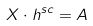<formula> <loc_0><loc_0><loc_500><loc_500>X \cdot h ^ { s c } = A</formula> 